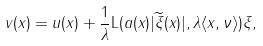Convert formula to latex. <formula><loc_0><loc_0><loc_500><loc_500>v ( x ) = u ( x ) + \frac { 1 } { \lambda } \mathrm L ( a ( x ) | \widetilde { \xi } ( x ) | , \lambda \langle x , \nu \rangle ) \xi ,</formula> 